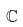<formula> <loc_0><loc_0><loc_500><loc_500>\mathbb { C }</formula> 